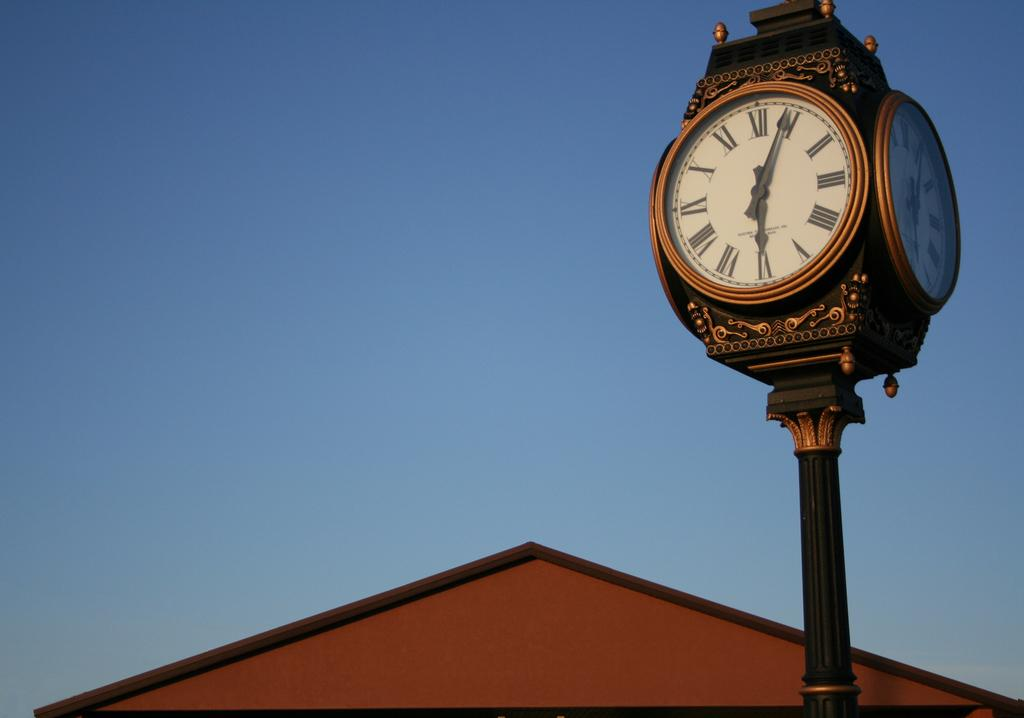Provide a one-sentence caption for the provided image. a clock tower with one of the dials pointing at 1. 